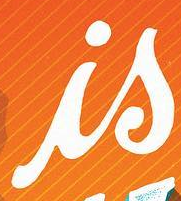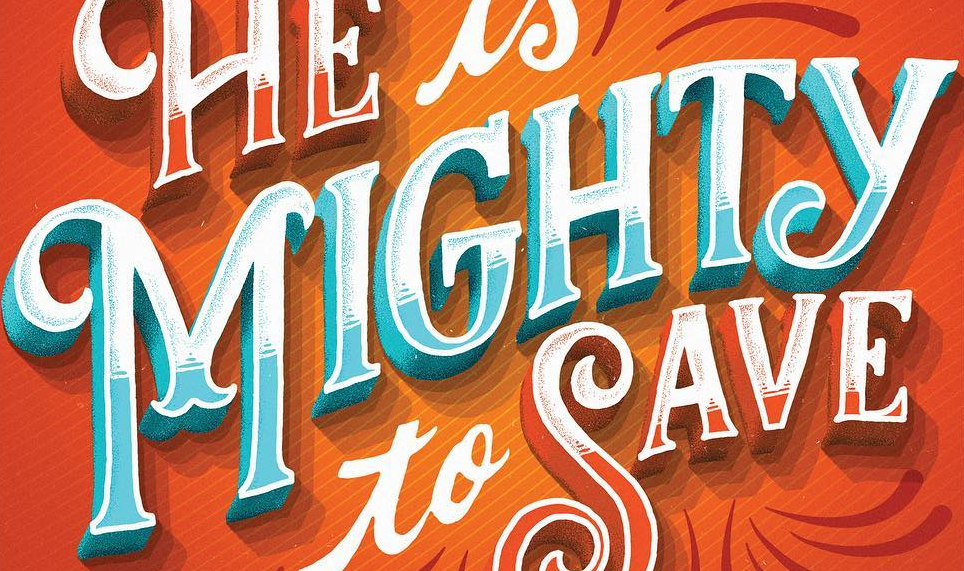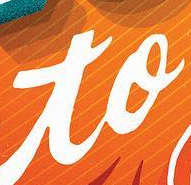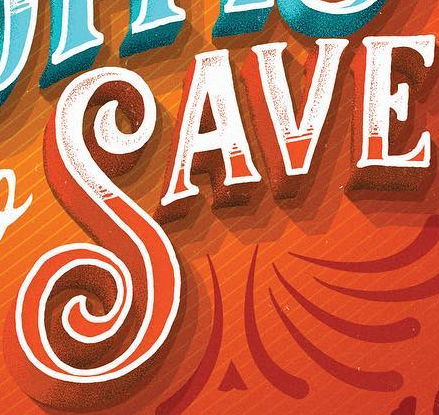Identify the words shown in these images in order, separated by a semicolon. is; MIGHTY; to; SAVE 